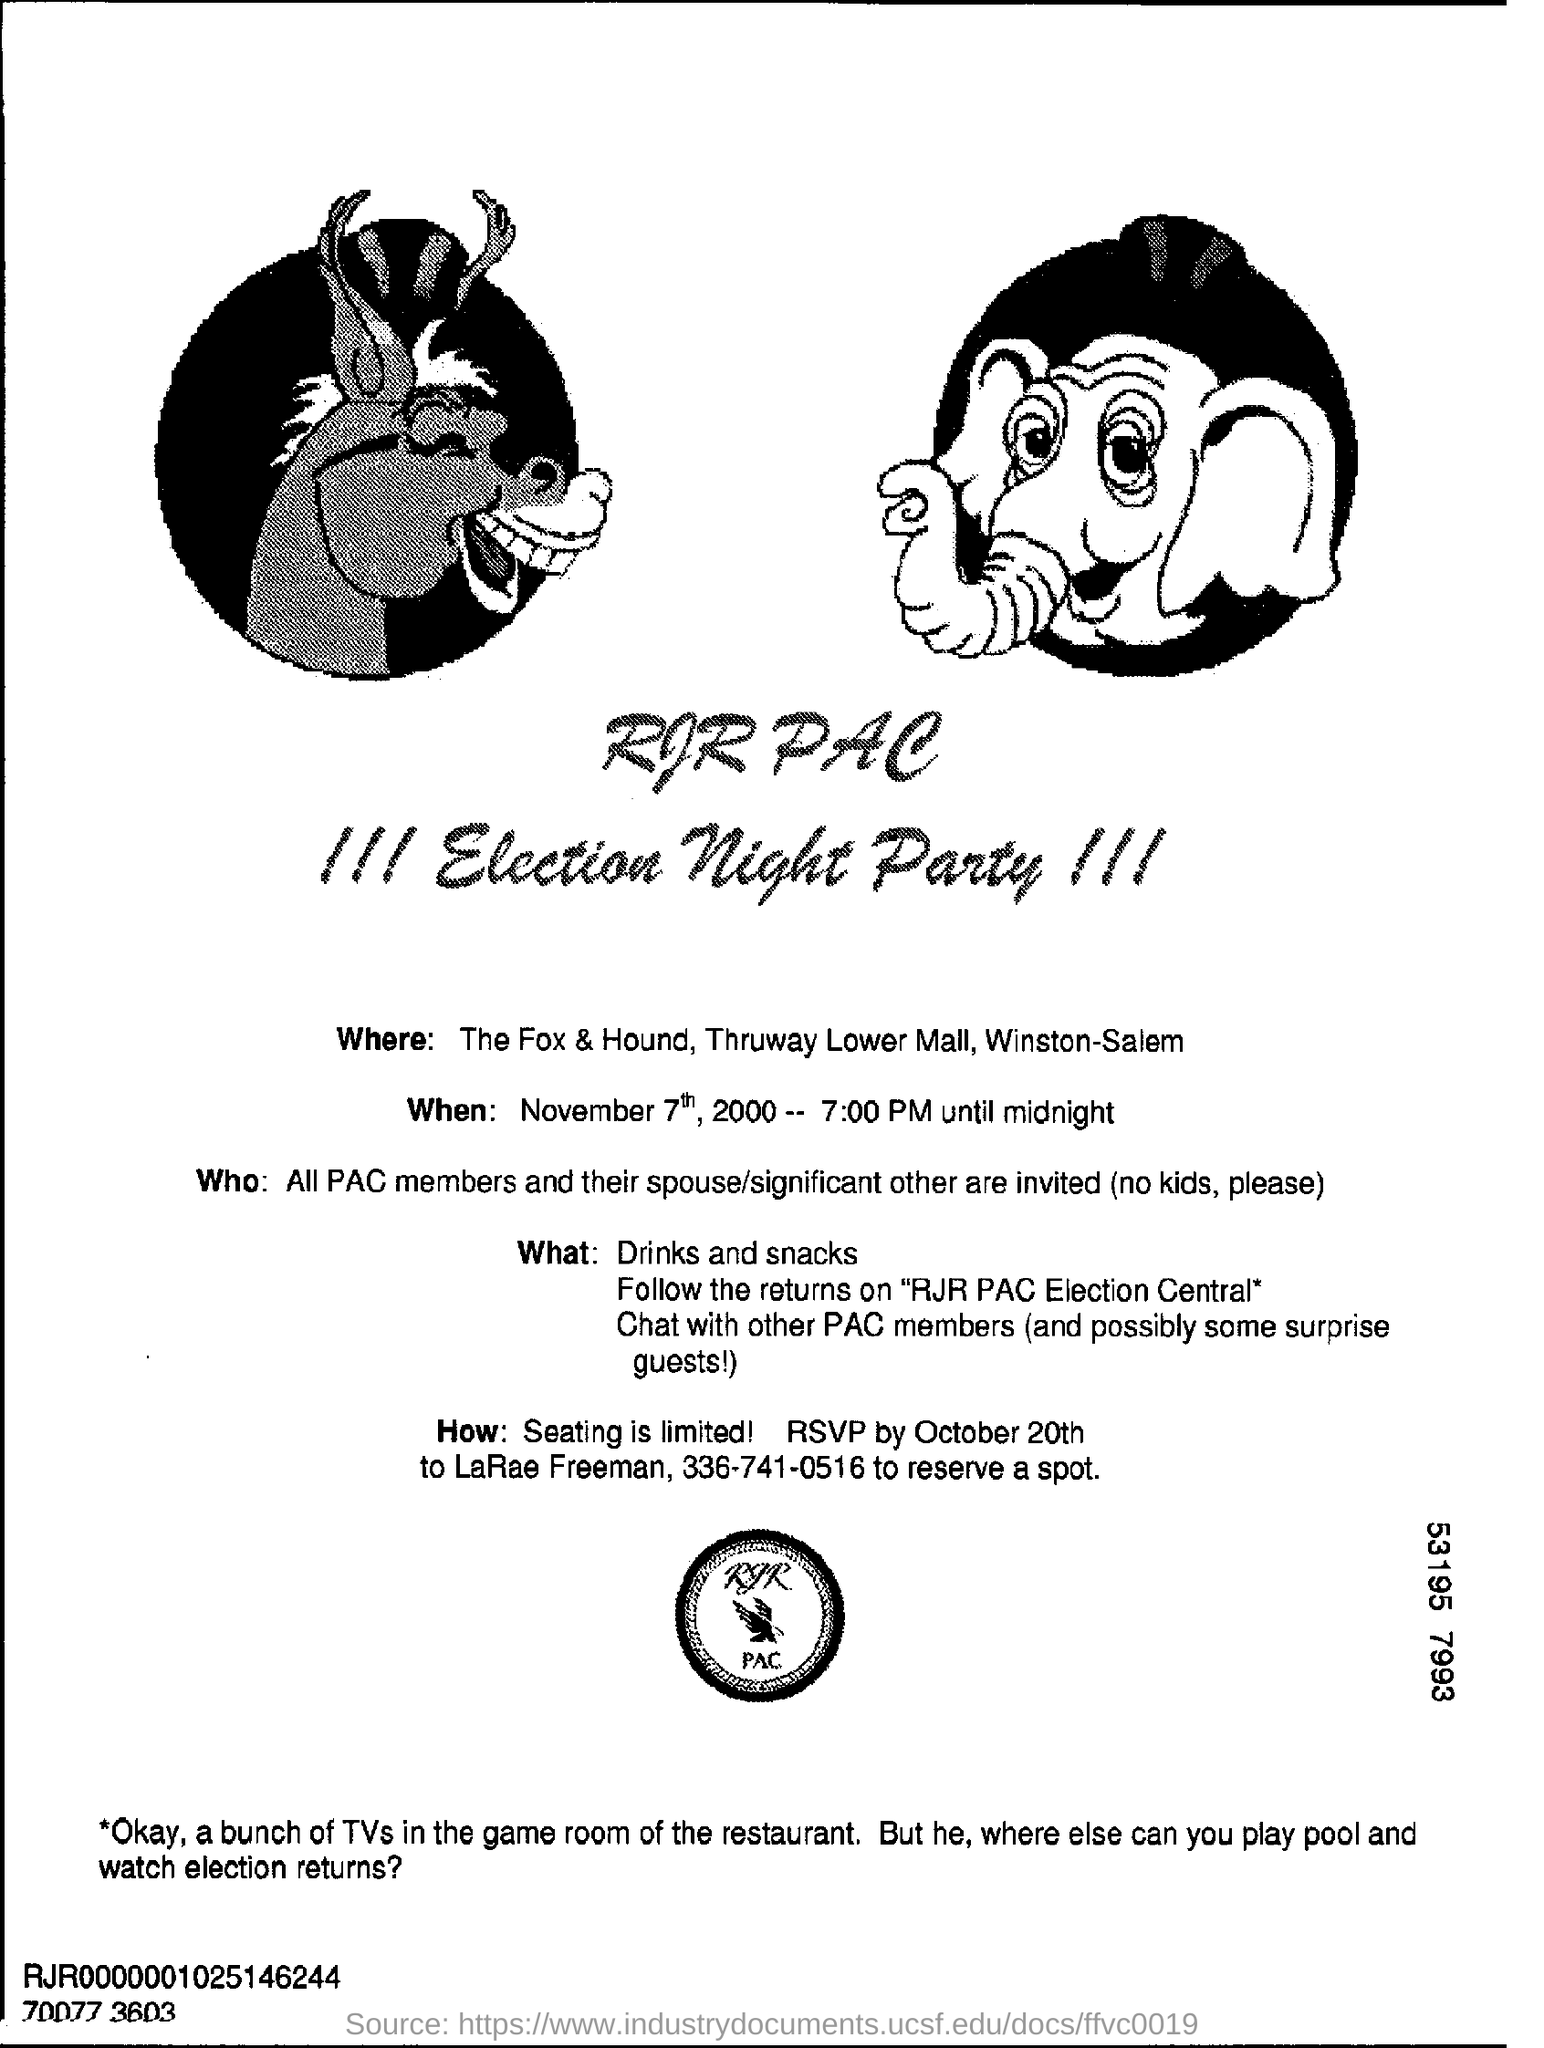Mention a couple of crucial points in this snapshot. To whom should RSVP be sent? LARAE FREEMAN should be sent. It is necessary for RSVPs to be sent by October 20th. On Election Night, the Election Night Party will be held at The Fox & Hound located in Thruway Lowermall, Winston-Salem. It is impermissible to bring children to the party, as stated in the invitation. To reserve a spot, please call the number 336-741-0516. 